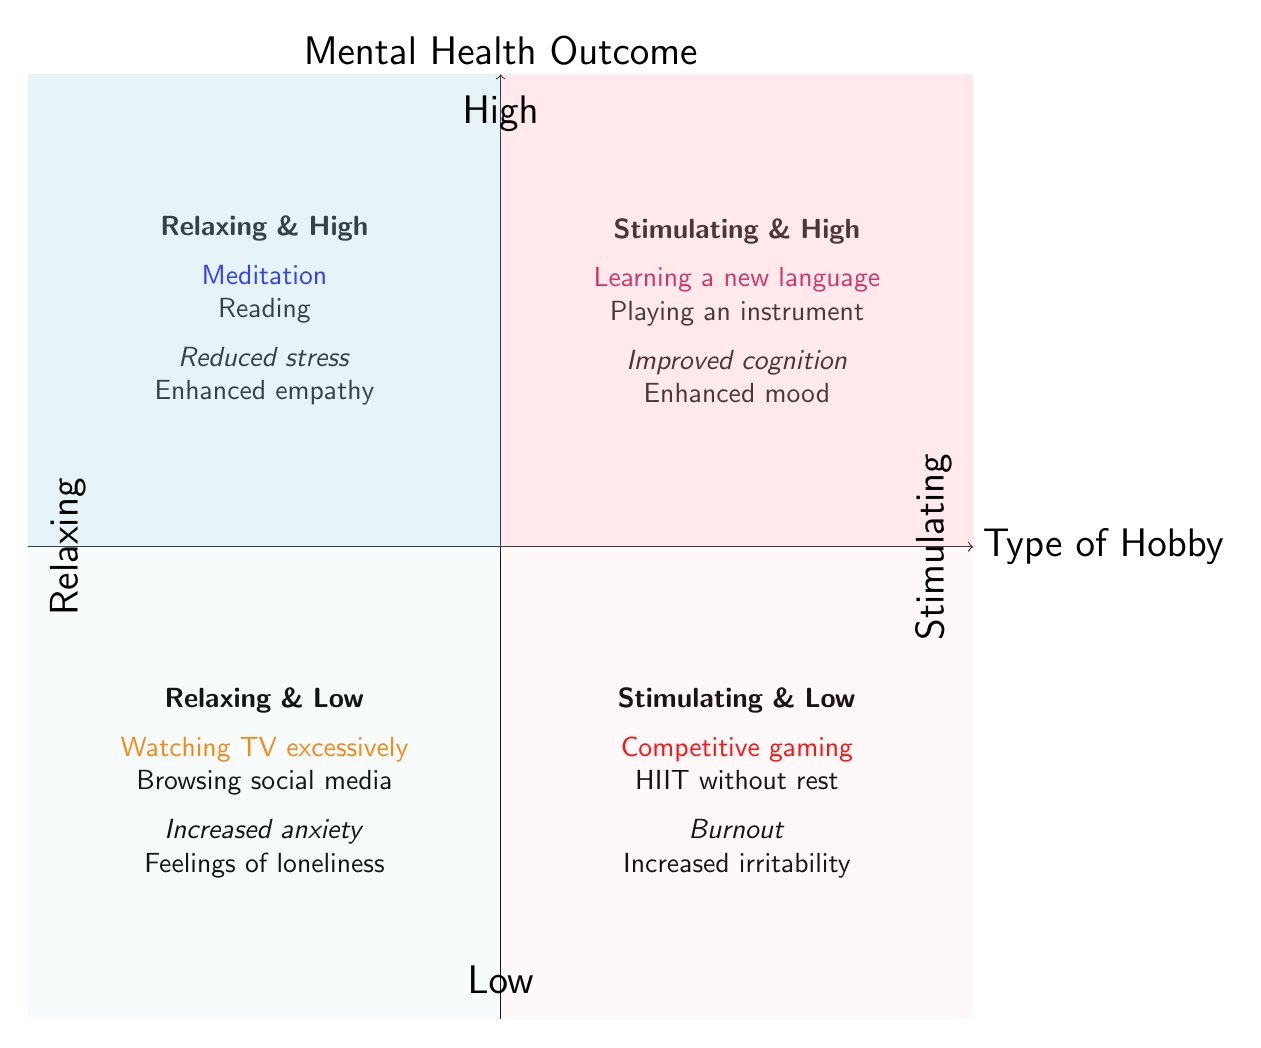What hobbies are in the Relaxing and High Mental Health Outcomes quadrant? The quadrant labeled "Relaxing & High" contains the activities "Meditation" and "Reading."
Answer: Meditation, Reading What are the mental health effects of Stimulating and Low Mental Health Outcomes hobbies? The "Stimulating & Low" quadrant lists "Burnout" and "Increased irritability" as the negative mental health outcomes associated with the hobbies in this category.
Answer: Burnout, Increased irritability How many activities are listed in the Relaxing and Low Mental Health Outcomes quadrant? The "Relaxing & Low" quadrant features two activities: "Watching TV excessively" and "Browsing social media." This confirms there are two activities present in this quadrant.
Answer: 2 Which quadrant contains activities that improve cognitive functions? The quadrant named "Stimulating & High" contains the activities that lead to improved cognitive functions, specifically "Learning a new language" and "Playing a musical instrument."
Answer: Stimulating and High What color represents the Relaxing quadrants in the diagram? The diagram uses a light blue color to represent the Relaxing quadrants. This is particularly visible in the areas occupied by the "Relaxing & High" and "Relaxing & Low" quadrants.
Answer: Light blue Which activity is associated with enhanced mood? The activity "Playing a musical instrument" in the "Stimulating & High" quadrant is associated with enhanced mood.
Answer: Playing a musical instrument How do relaxing hobbies generally affect mental health outcomes compared to stimulating hobbies? The diagram indicates that relaxing hobbies lead to either high or low mental health outcomes, while stimulating hobbies can also result in similarly high or low outcomes. This suggests both types of activities can vary widely in their impact on mental health, distinguishing their effects.
Answer: Vary widely in impact 